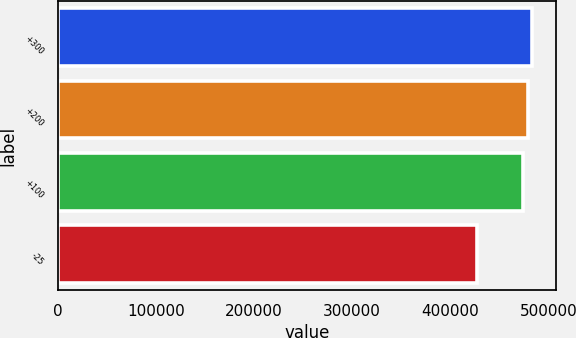<chart> <loc_0><loc_0><loc_500><loc_500><bar_chart><fcel>+300<fcel>+200<fcel>+100<fcel>-25<nl><fcel>483809<fcel>478974<fcel>474138<fcel>427767<nl></chart> 